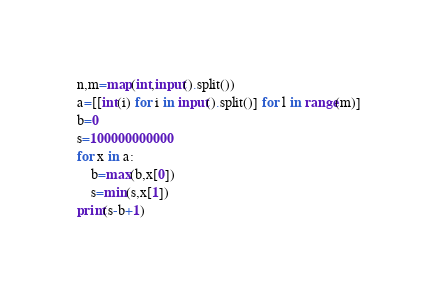Convert code to text. <code><loc_0><loc_0><loc_500><loc_500><_Python_>n,m=map(int,input().split())
a=[[int(i) for i in input().split()] for l in range(m)]
b=0
s=100000000000
for x in a:
    b=max(b,x[0])
    s=min(s,x[1])
print(s-b+1)</code> 